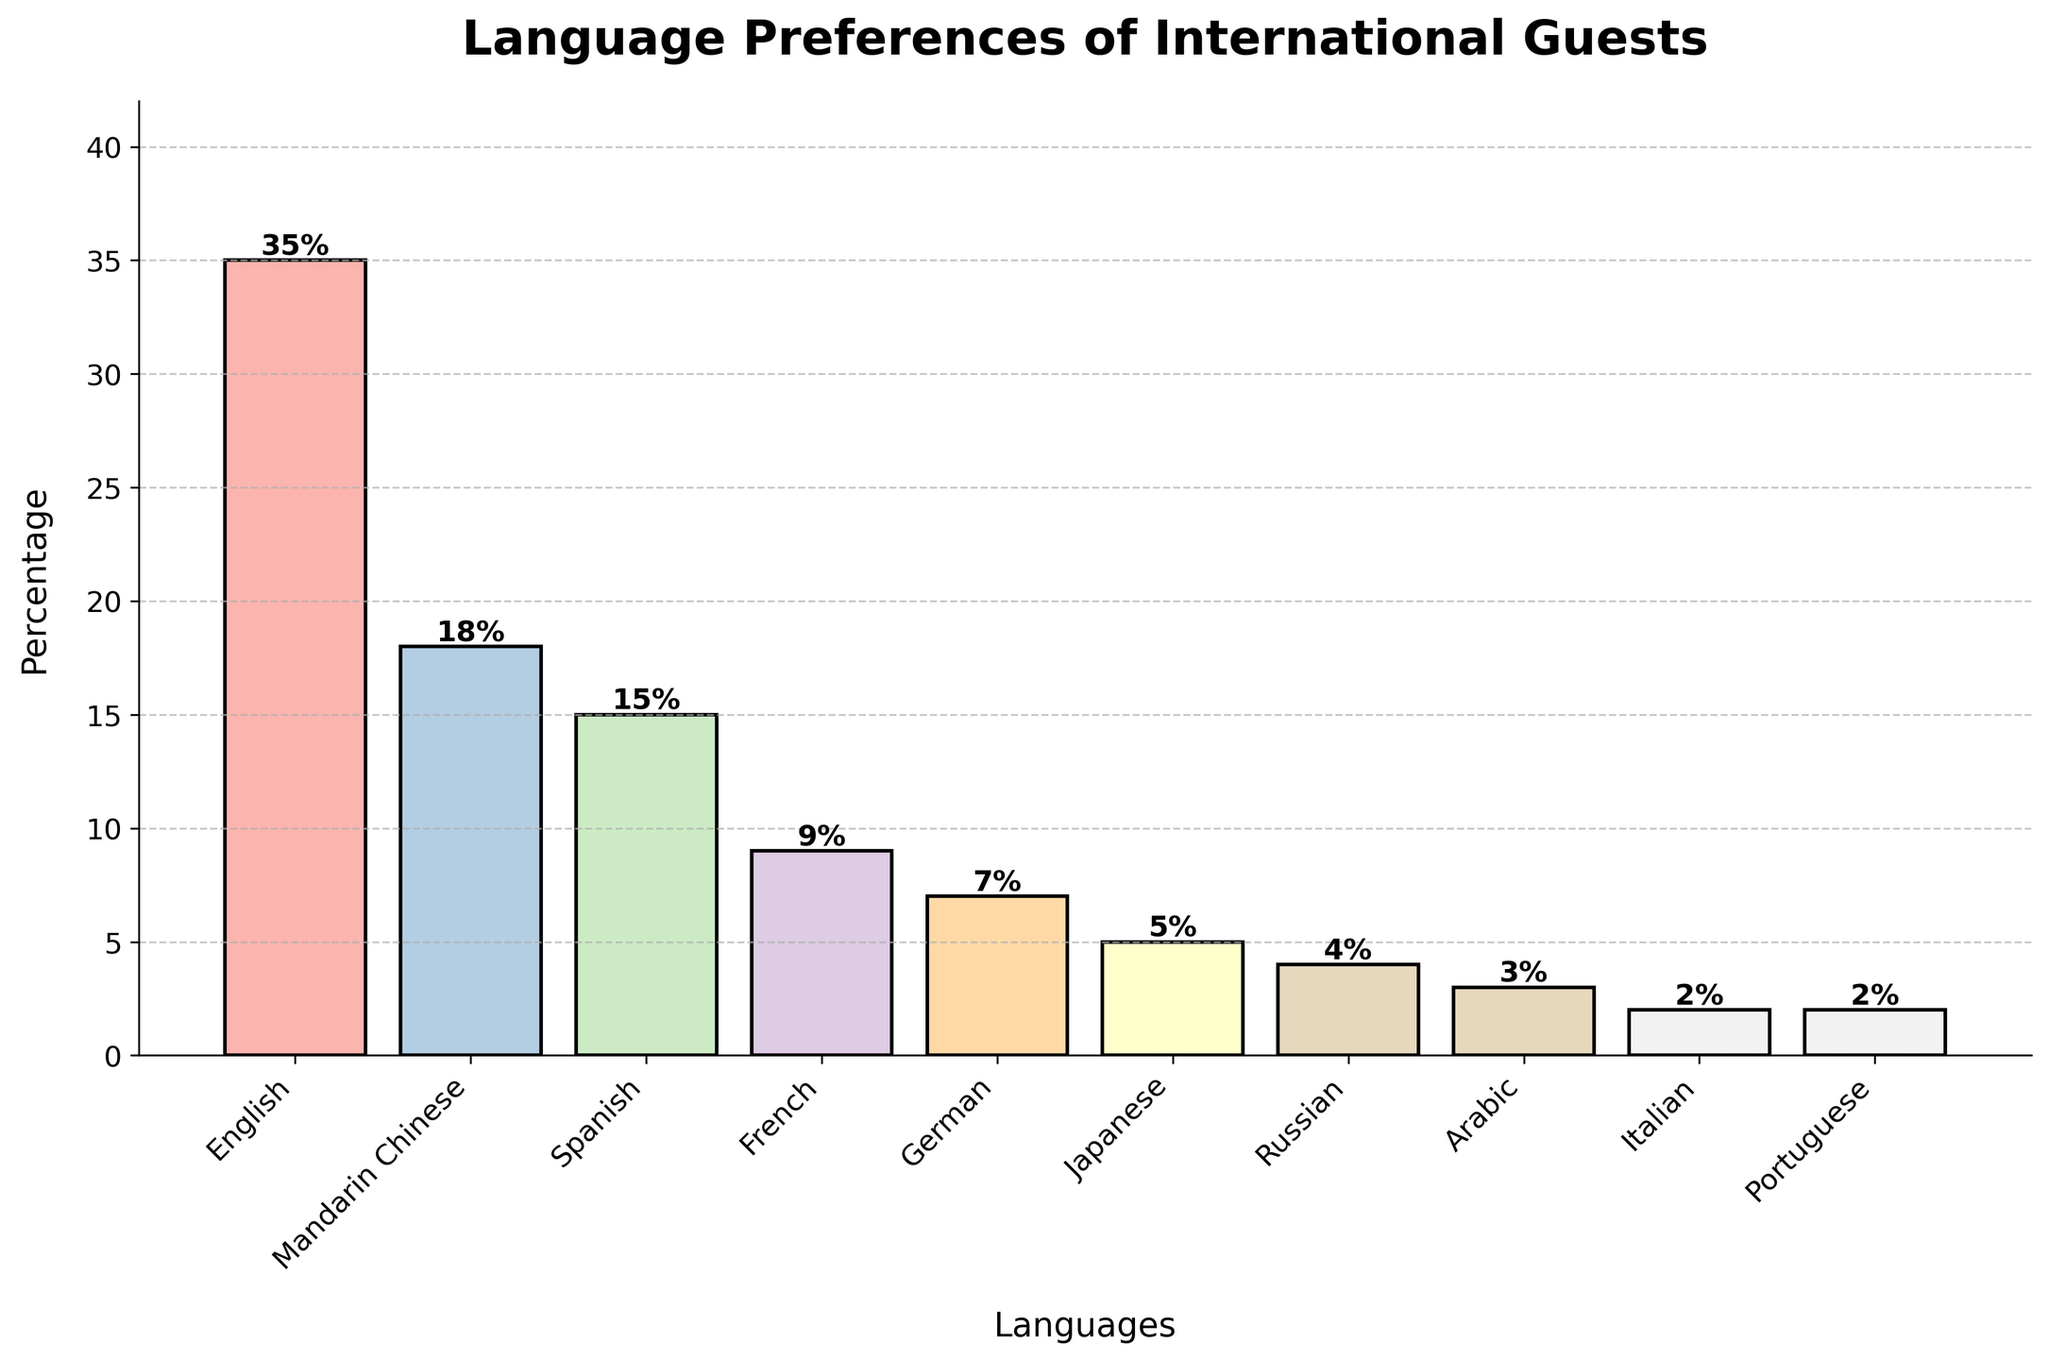what's the most preferred language among international guests? The tallest bar represents the most preferred language, which is English with 35%
Answer: English which language has the second highest preference? The second tallest bar shows the preference for Mandarin Chinese, with an 18% value
Answer: Mandarin Chinese how many languages have a preference of below 10%? By visually inspecting the bars, the languages French, German, Japanese, Russian, Arabic, Italian, and Portuguese all have preferences below 10%. Counting these gives us 7 languages
Answer: 7 what is the combined percentage of guests preferring Spanish and French? The height of the bars for Spanish and French represent 15% and 9%, respectively. Adding these gives us 15% + 9% = 24%
Answer: 24% which language group has the smallest percentage? The shortest bar in the chart corresponds to Italian and Portuguese, both with a 2% preference
Answer: Italian, Portuguese is the preference for Japanese greater than that for Russian? The bar for Japanese represents 5%, while the bar for Russian is at 4%. Thus, Japanese has a greater preference than Russian
Answer: Yes what is the total percentage for the top three preferred languages? Summing the percentages for the top three bars (English, Mandarin Chinese, and Spanish), we get 35% + 18% + 15% = 68%
Answer: 68% among the listed languages, how many have a preference between 3% and 7%? By visually analyzing the chart, German (7%), Japanese (5%), Russian (4%), and Arabic (3%) fall within this range. Counting these gives us 4 languages
Answer: 4 which two languages have the most similar preference levels? By comparing the heights of the bars closely, Italian and Portuguese both show a similar preference of 2%
Answer: Italian, Portuguese what is the average percentage preference across all the languages? Summing all percentages (35% + 18% + 15% + 9% + 7% + 5% + 4% + 3% + 2% + 2%) = 100%. Then, dividing by the number of languages (10), 100% / 10 = 10%
Answer: 10% 